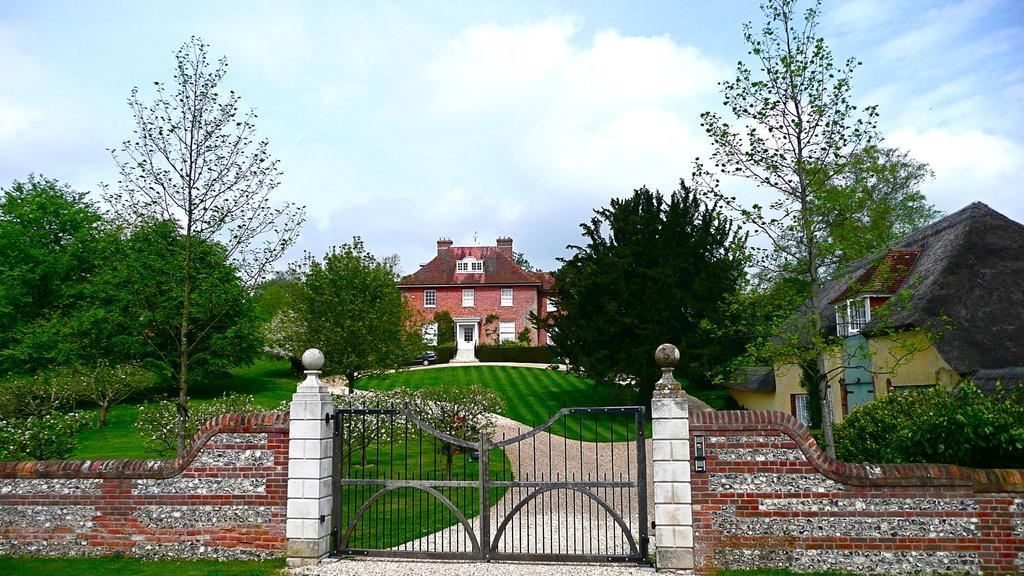In one or two sentences, can you explain what this image depicts? In this image there is a gate attached to the wall. There are plants and trees on the grassland. Background there are buildings. Top of the image there is sky with some clouds. 